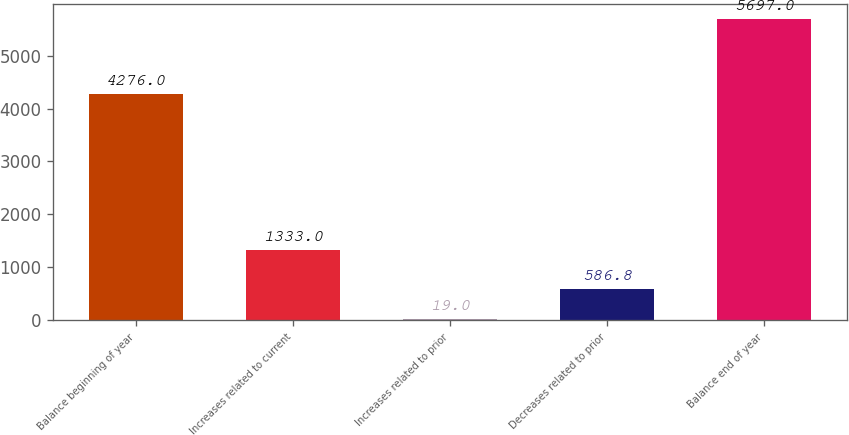Convert chart to OTSL. <chart><loc_0><loc_0><loc_500><loc_500><bar_chart><fcel>Balance beginning of year<fcel>Increases related to current<fcel>Increases related to prior<fcel>Decreases related to prior<fcel>Balance end of year<nl><fcel>4276<fcel>1333<fcel>19<fcel>586.8<fcel>5697<nl></chart> 